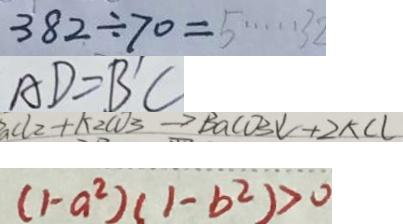<formula> <loc_0><loc_0><loc_500><loc_500>3 8 2 \div 7 0 = 5 \cdots 3 2 
 A D = B ^ { \prime } C 
 _ { a } C l _ { 2 } + k _ { 2 } c o _ { 3 } \rightarrow B a c o _ { 3 } \downarrow + 2 k C l 
 ( 1 - a ^ { 2 } ) ( 1 - b ^ { 2 } ) > 0</formula> 